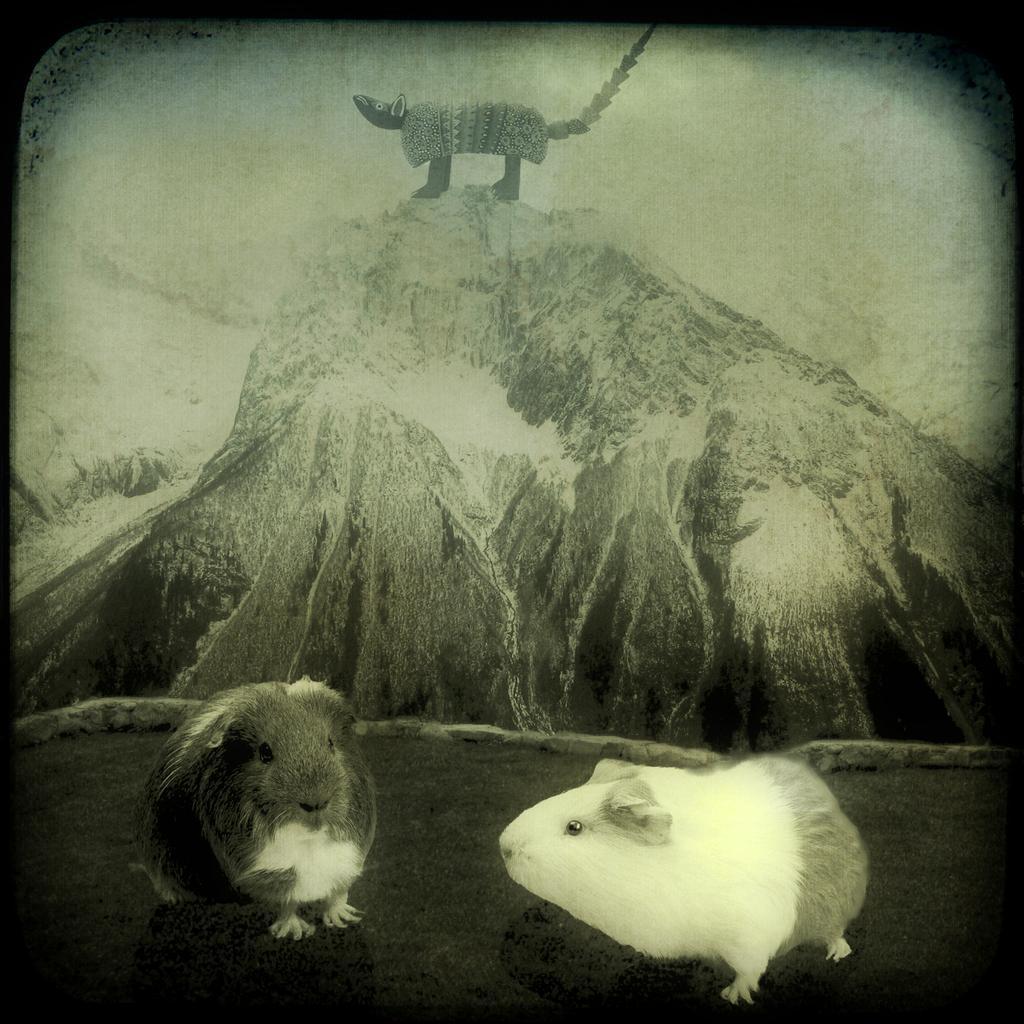Please provide a concise description of this image. It is a black and white image. In this image we can see the depiction of three rats. Two on the land and one on the rock hill and the image has borders. 